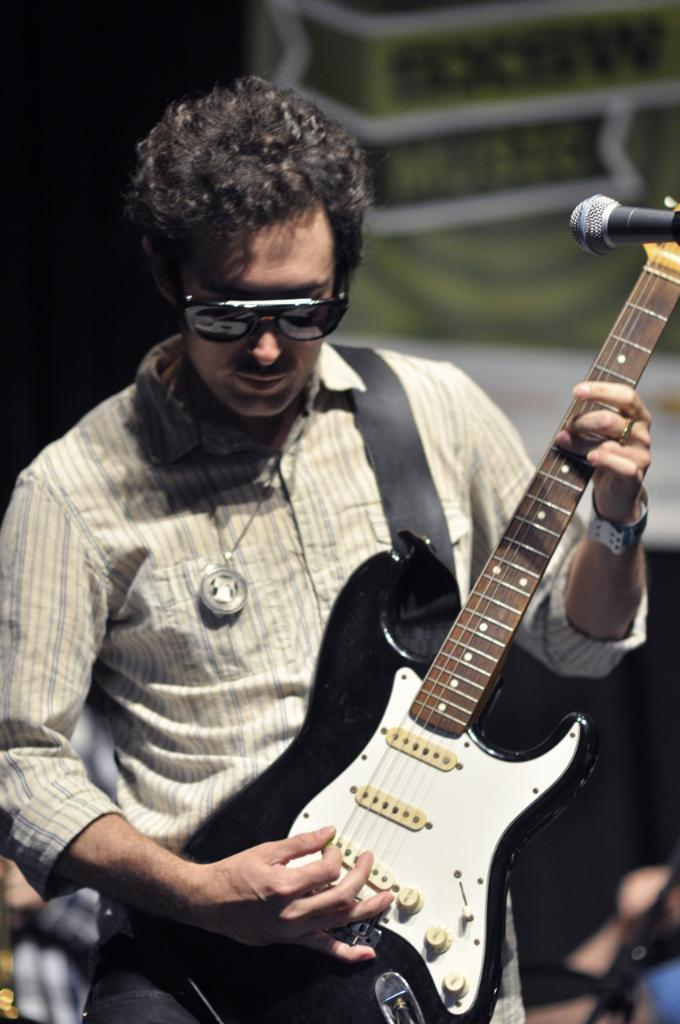Who is present in the image? There is a man in the image. What is the man holding in the image? The man is holding a guitar. What other object can be seen in the image? There is a microphone in the image. How many legs does the man's mom have in the image? There is no mention of the man's mom in the image, so it is impossible to determine the number of legs she might have. 